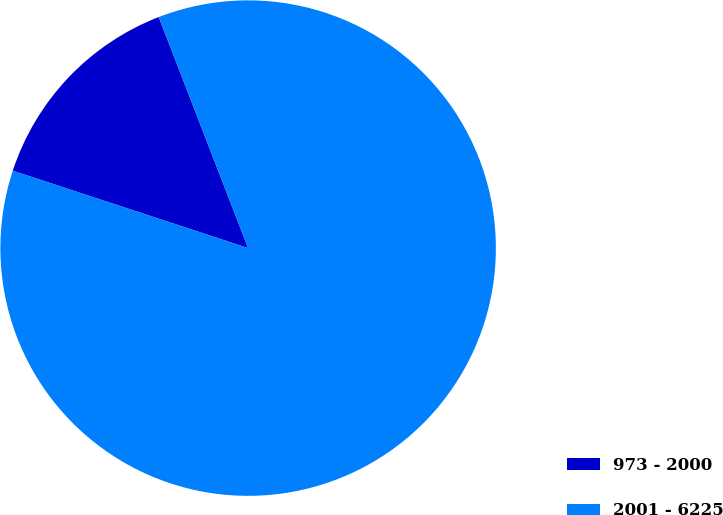Convert chart to OTSL. <chart><loc_0><loc_0><loc_500><loc_500><pie_chart><fcel>973 - 2000<fcel>2001 - 6225<nl><fcel>14.07%<fcel>85.93%<nl></chart> 